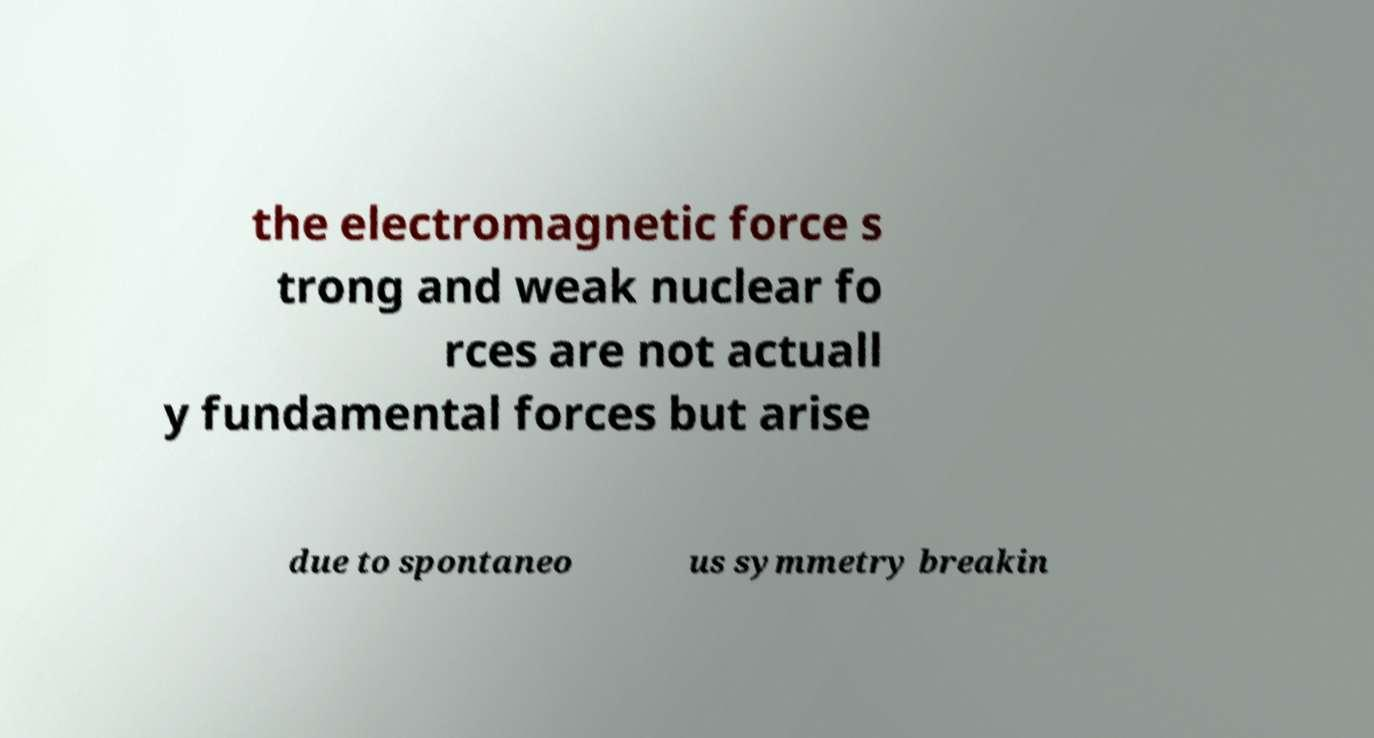Please identify and transcribe the text found in this image. the electromagnetic force s trong and weak nuclear fo rces are not actuall y fundamental forces but arise due to spontaneo us symmetry breakin 